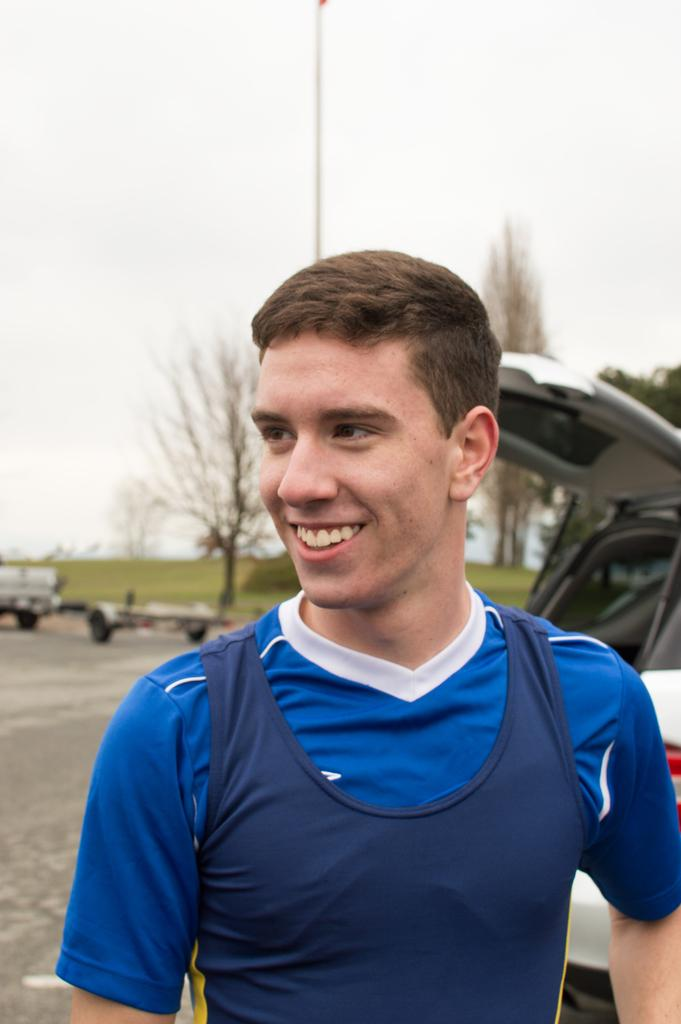What is the main subject of the image? There is a person in the image. What is the person doing in the image? The person is smiling. In which direction is the person looking? The person is looking to the left side. What can be seen in the background of the image? There are vehicles, a road, trees, plants, grass, and the sky visible in the background. Can you describe the pole in the image? Yes, there is a pole in the image. What type of advice can be heard coming from the mine in the image? There is no mine present in the image, so it's not possible to determine what, if any, advice might be heard. 